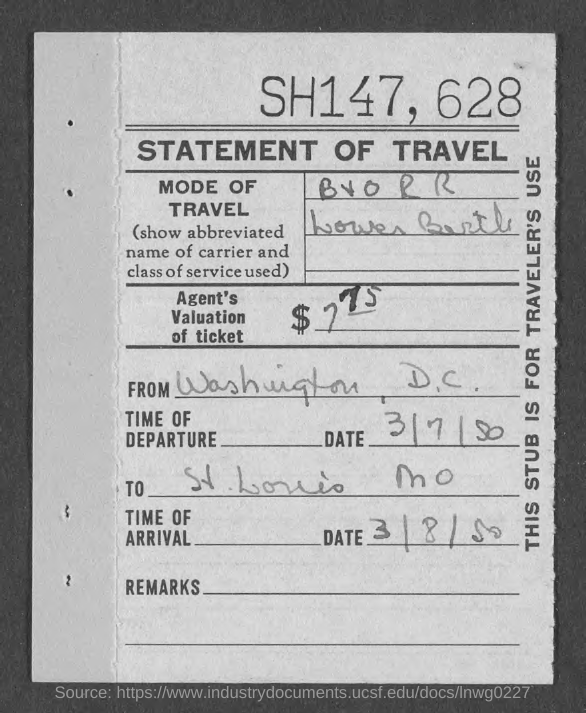What is the Title of the document?
Your answer should be very brief. STATEMENT OF TRAVEL. When is the Date of departure?
Keep it short and to the point. 3/7/50. When is the Date of arrival?
Your answer should be very brief. 3/8/50. Where is it to?
Provide a succinct answer. St. Louis MO. What is this stub for?
Offer a terse response. TRAVELER'S USE. 